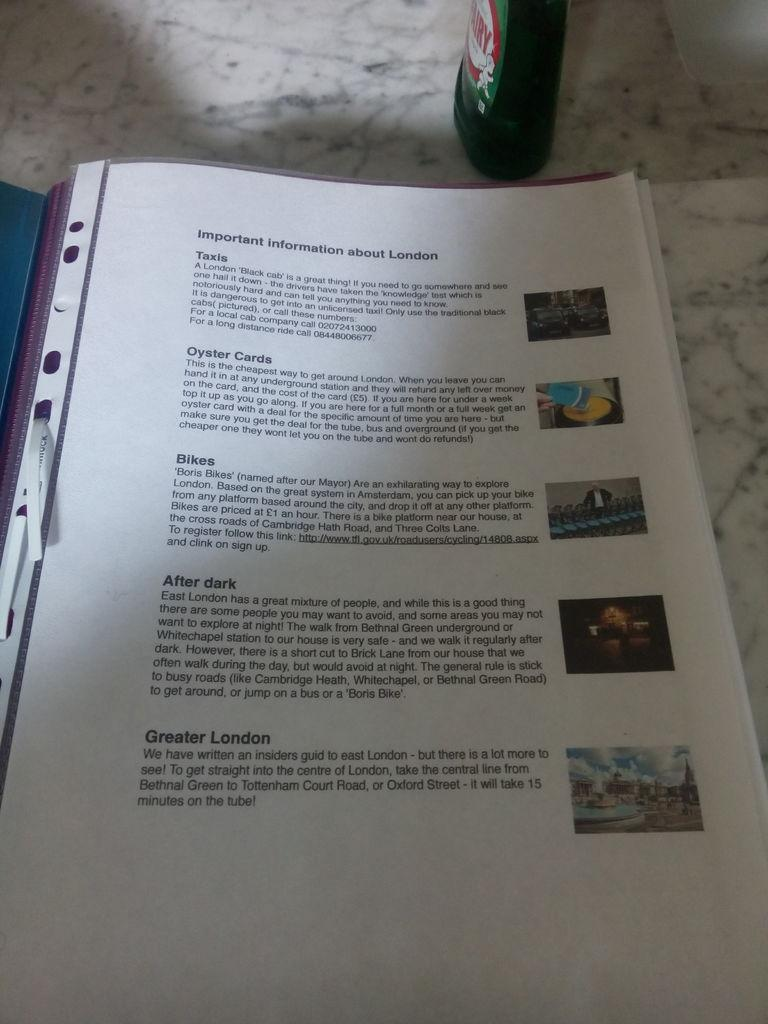<image>
Present a compact description of the photo's key features. The page of a booklet showing important information about London. 